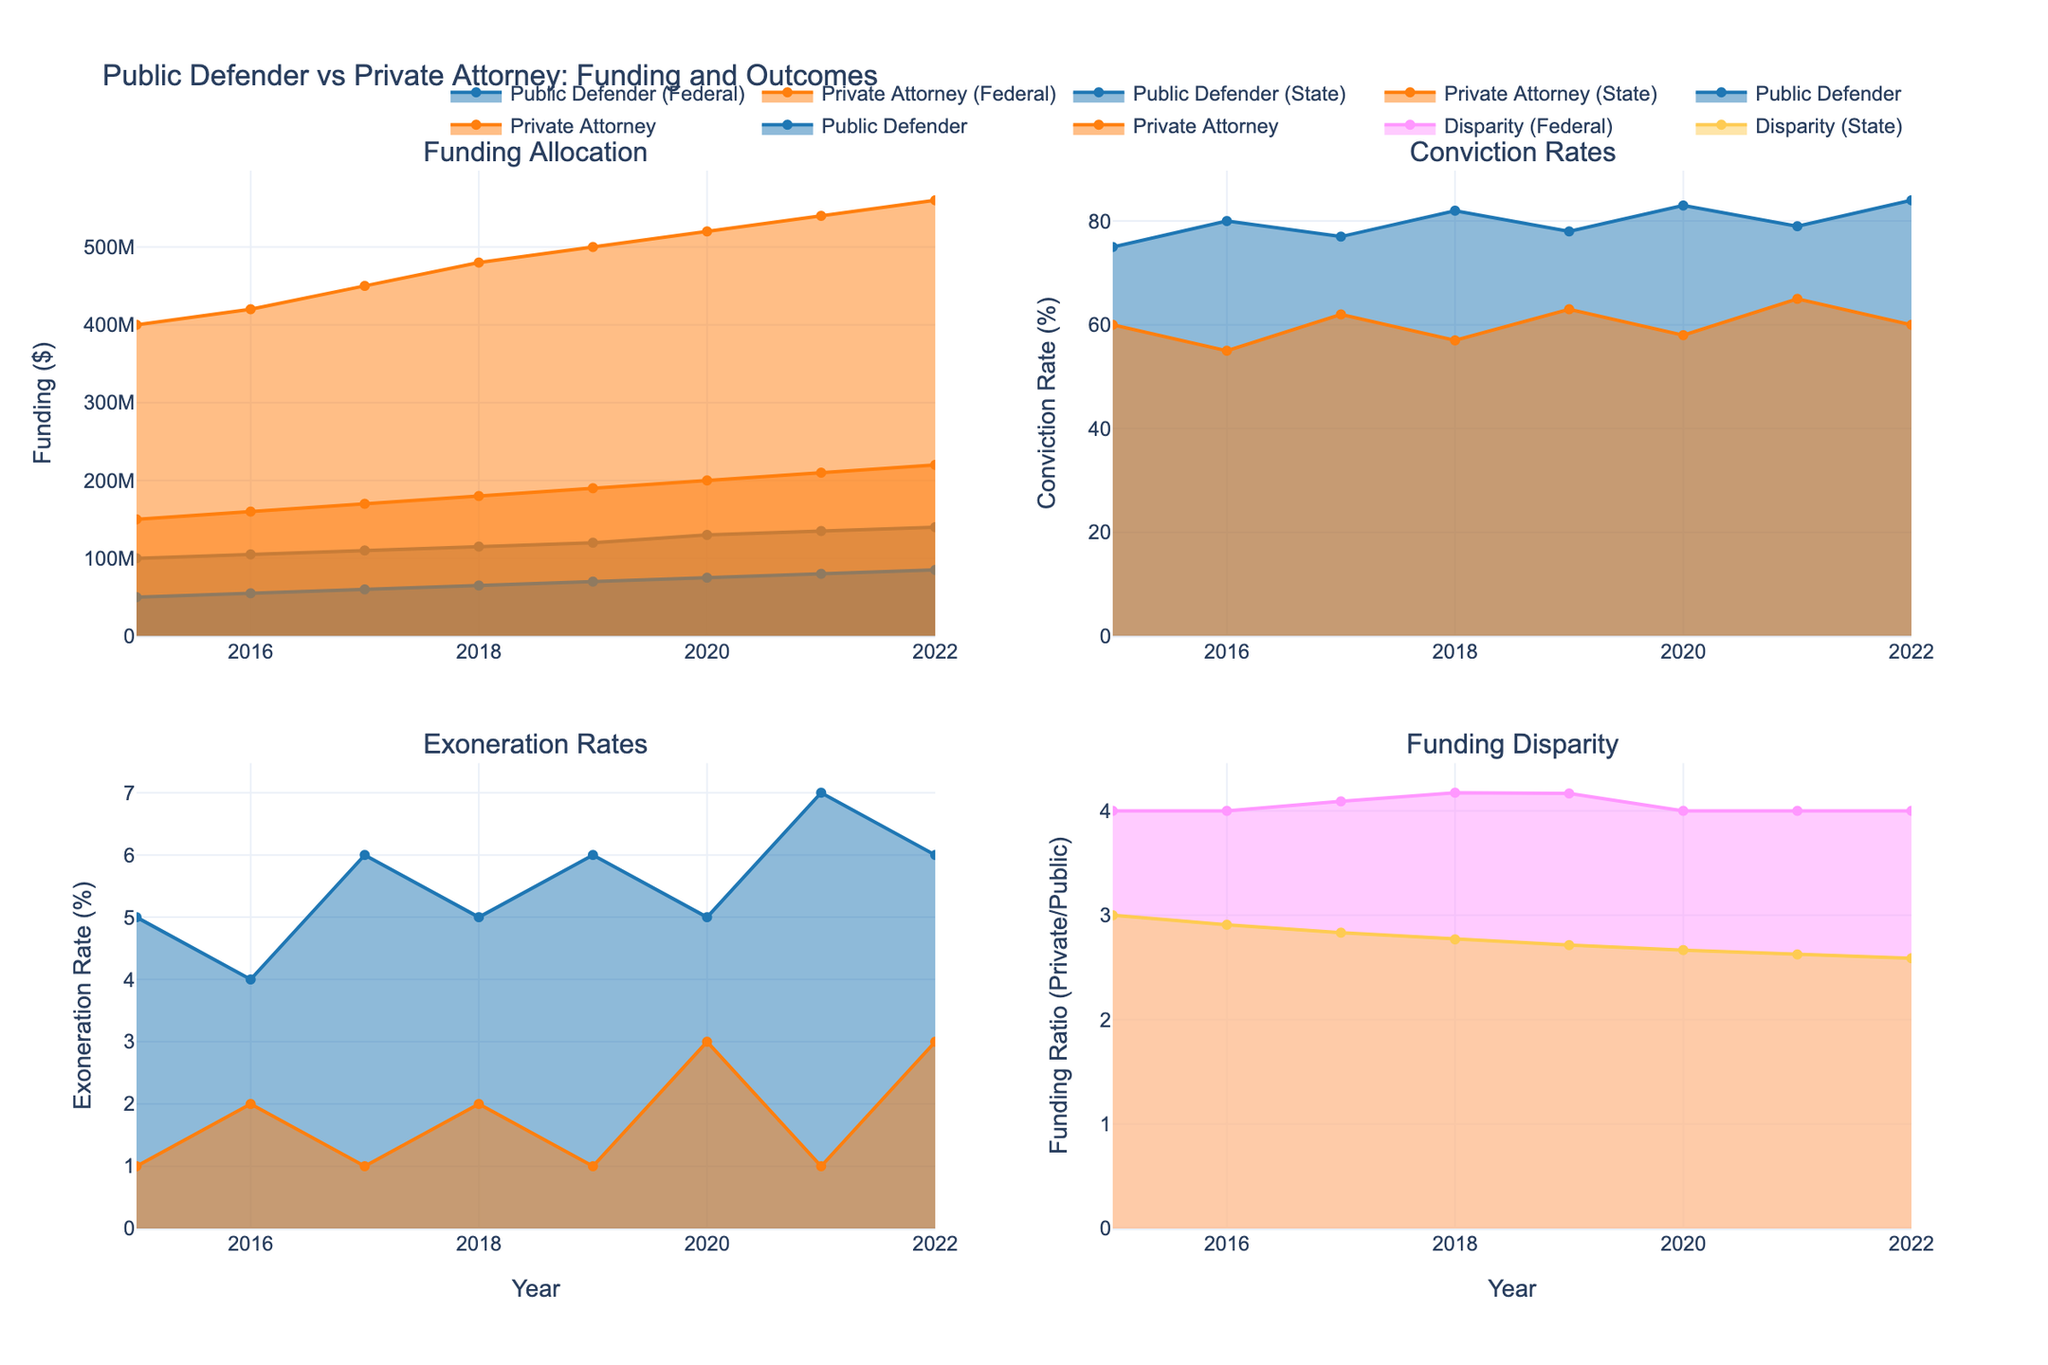what is the title of the figure? The title is displayed at the top of the figure.
Answer: Public Defender vs Private Attorney: Funding and Outcomes which category has a higher conviction rate in 2022? In the Conviction Rates subplot, compare the values for Public Defender and Private Attorney in 2022.
Answer: Private Attorney how does the funding for public defenders and private attorneys in state cases compare in 2016? In the Funding Allocation subplot, locate the funding for Public Defender and Private Attorney for state cases in 2016 and compare the amounts.
Answer: Public Defender: $55,000,000, Private Attorney: $160,000,000 by how much did the funding for federal public defenders increase from 2015 to 2022? In the Funding Allocation subplot, subtract the funding amount for 2015 from that of 2022 for Federal Public Defenders.
Answer: $40,000,000 which category consistently has a higher exoneration rate throughout the years? In the Exoneration Rates subplot, observe the trends for Public Defender and Private Attorney across all the years and identify which category has consistently higher values.
Answer: Public Defender is there a year where the conviction rate for public defenders exceeded 80%? If yes, which year? In the Conviction Rates subplot, locate the points where the Public Defender Conviction Rate is greater than 80%.
Answer: Yes, 2019, 2020, 2021, and 2022 calculate the average funding disparity between private attorneys and public defenders across all years for federal cases. In the Funding Disparity subplot for Federal cases, sum up all disparity values and divide by the number of years (8). Example: (4+4+4+4+4+4+4+4)/8 = 4
Answer: 4 what is the trend of the exoneration rate for state public defenders from 2015 to 2022? In the Exoneration Rates subplot, observe the changes in the exoneration rate for state Public Defenders across all years.
Answer: Increasing during which years was the conviction rate for public defenders lower than that for private attorneys? In the Conviction Rates subplot, compare the Public Defender and Private Attorney Conviction Rates for each year and identify when Public Defender Conviction Rate was lower.
Answer: None 